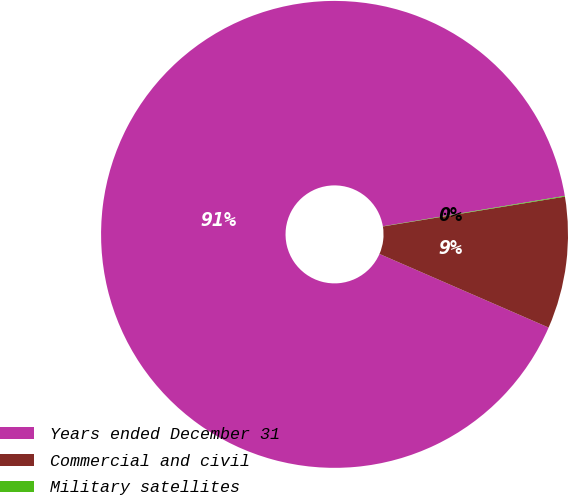<chart> <loc_0><loc_0><loc_500><loc_500><pie_chart><fcel>Years ended December 31<fcel>Commercial and civil<fcel>Military satellites<nl><fcel>90.83%<fcel>9.12%<fcel>0.05%<nl></chart> 